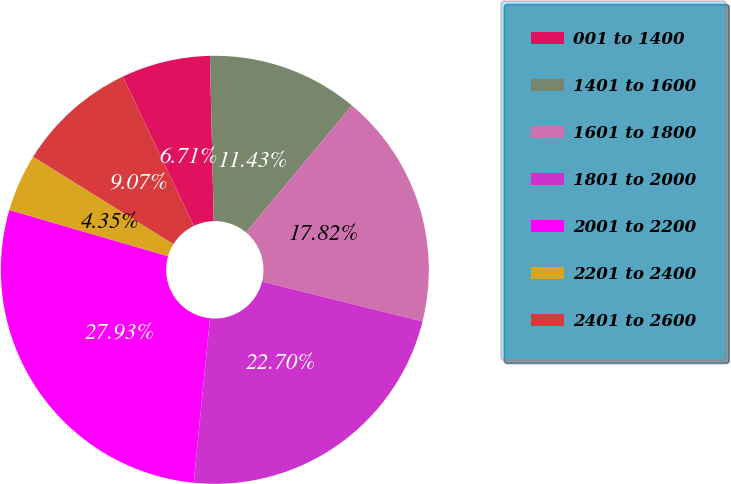Convert chart to OTSL. <chart><loc_0><loc_0><loc_500><loc_500><pie_chart><fcel>001 to 1400<fcel>1401 to 1600<fcel>1601 to 1800<fcel>1801 to 2000<fcel>2001 to 2200<fcel>2201 to 2400<fcel>2401 to 2600<nl><fcel>6.71%<fcel>11.43%<fcel>17.82%<fcel>22.7%<fcel>27.94%<fcel>4.35%<fcel>9.07%<nl></chart> 